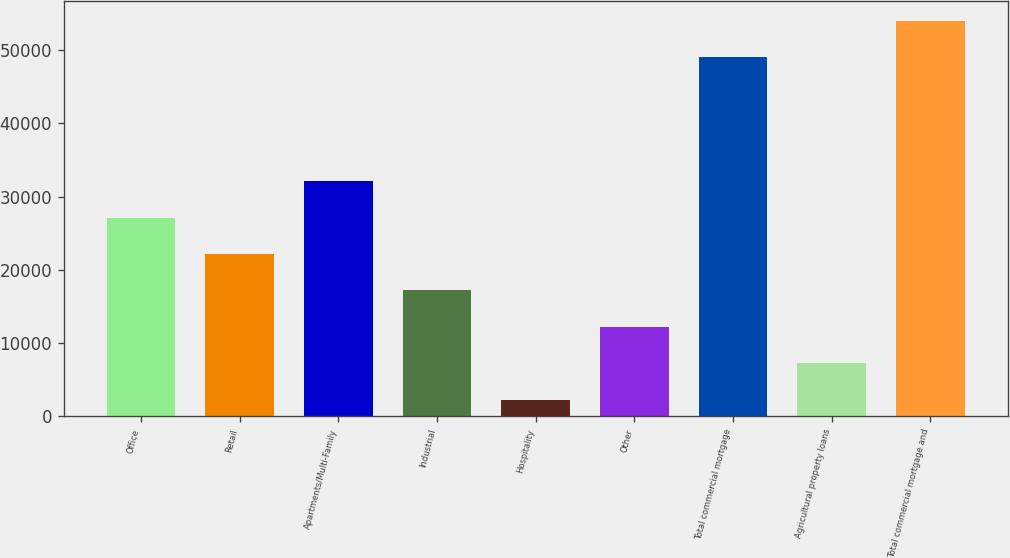Convert chart to OTSL. <chart><loc_0><loc_0><loc_500><loc_500><bar_chart><fcel>Office<fcel>Retail<fcel>Apartments/Multi-Family<fcel>Industrial<fcel>Hospitality<fcel>Other<fcel>Total commercial mortgage<fcel>Agricultural property loans<fcel>Total commercial mortgage and<nl><fcel>27129.5<fcel>22158.4<fcel>32100.6<fcel>17187.3<fcel>2274<fcel>12216.2<fcel>49027<fcel>7245.1<fcel>53998.1<nl></chart> 